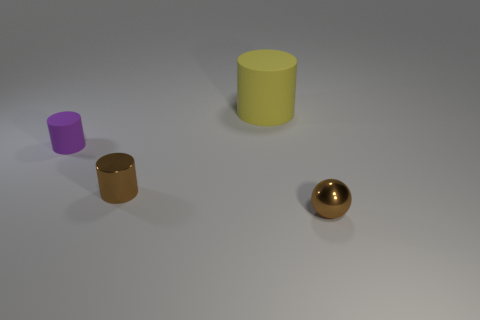Subtract all rubber cylinders. How many cylinders are left? 1 Add 1 large yellow shiny objects. How many objects exist? 5 Subtract all purple cylinders. How many cylinders are left? 2 Subtract all balls. How many objects are left? 3 Subtract 2 cylinders. How many cylinders are left? 1 Subtract all yellow cylinders. Subtract all blue blocks. How many cylinders are left? 2 Subtract all purple blocks. How many red balls are left? 0 Subtract all shiny balls. Subtract all metal objects. How many objects are left? 1 Add 4 brown metal things. How many brown metal things are left? 6 Add 2 big yellow cylinders. How many big yellow cylinders exist? 3 